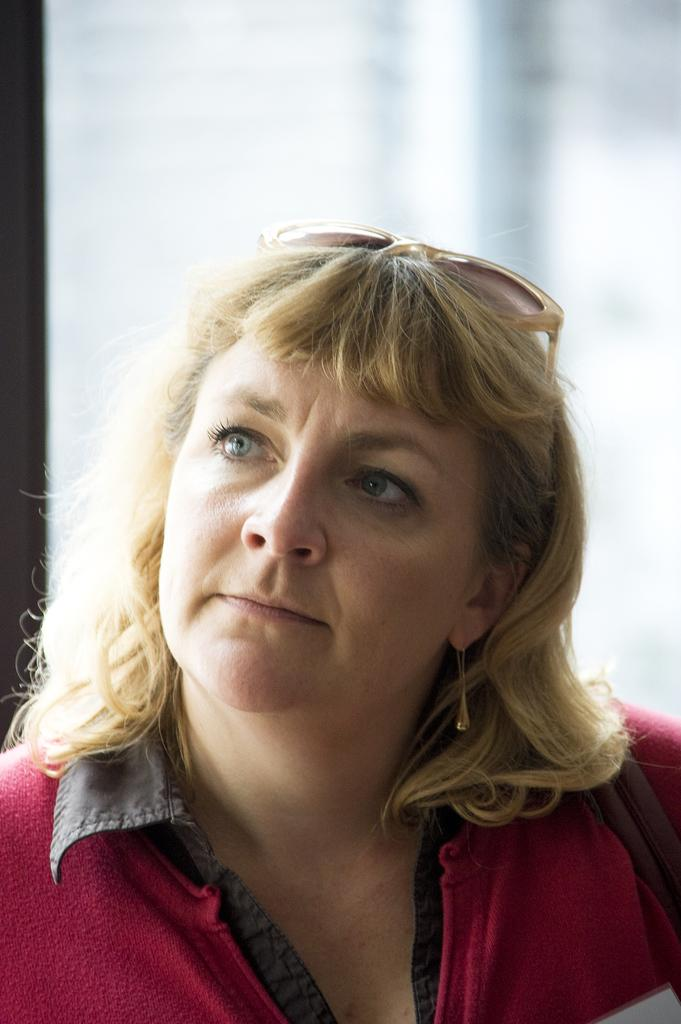Who is the main subject in the image? There is a woman in the image. What is the woman wearing? The woman is wearing a pink dress. Are there any accessories visible on the woman? Yes, the woman has goggles on her head. What song is the woman singing in the image? There is no indication in the image that the woman is singing, so it cannot be determined from the picture. 